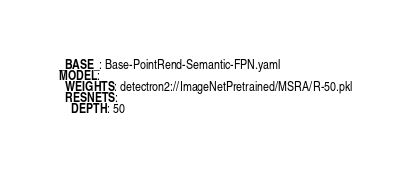<code> <loc_0><loc_0><loc_500><loc_500><_YAML_>_BASE_: Base-PointRend-Semantic-FPN.yaml
MODEL:
  WEIGHTS: detectron2://ImageNetPretrained/MSRA/R-50.pkl
  RESNETS:
    DEPTH: 50
</code> 